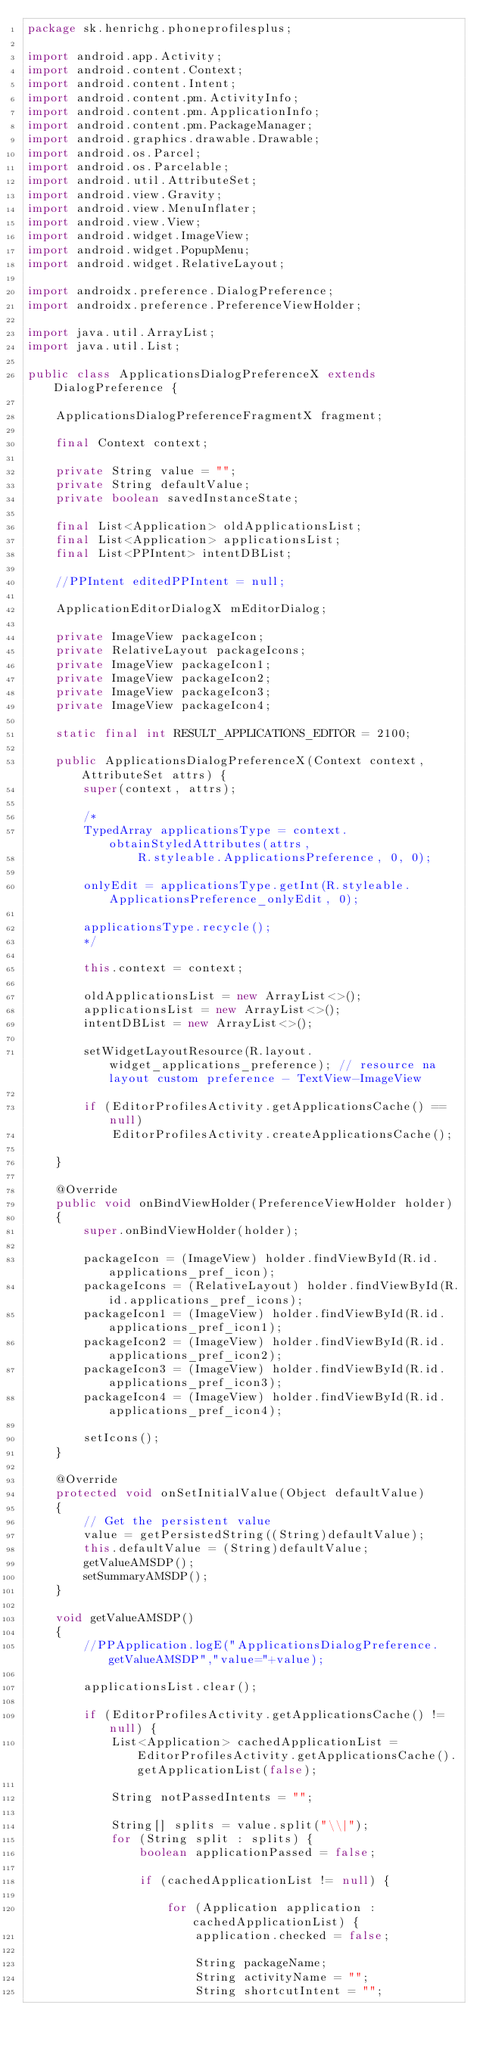Convert code to text. <code><loc_0><loc_0><loc_500><loc_500><_Java_>package sk.henrichg.phoneprofilesplus;

import android.app.Activity;
import android.content.Context;
import android.content.Intent;
import android.content.pm.ActivityInfo;
import android.content.pm.ApplicationInfo;
import android.content.pm.PackageManager;
import android.graphics.drawable.Drawable;
import android.os.Parcel;
import android.os.Parcelable;
import android.util.AttributeSet;
import android.view.Gravity;
import android.view.MenuInflater;
import android.view.View;
import android.widget.ImageView;
import android.widget.PopupMenu;
import android.widget.RelativeLayout;

import androidx.preference.DialogPreference;
import androidx.preference.PreferenceViewHolder;

import java.util.ArrayList;
import java.util.List;

public class ApplicationsDialogPreferenceX extends DialogPreference {

    ApplicationsDialogPreferenceFragmentX fragment;

    final Context context;

    private String value = "";
    private String defaultValue;
    private boolean savedInstanceState;

    final List<Application> oldApplicationsList;
    final List<Application> applicationsList;
    final List<PPIntent> intentDBList;

    //PPIntent editedPPIntent = null;

    ApplicationEditorDialogX mEditorDialog;

    private ImageView packageIcon;
    private RelativeLayout packageIcons;
    private ImageView packageIcon1;
    private ImageView packageIcon2;
    private ImageView packageIcon3;
    private ImageView packageIcon4;

    static final int RESULT_APPLICATIONS_EDITOR = 2100;

    public ApplicationsDialogPreferenceX(Context context, AttributeSet attrs) {
        super(context, attrs);

        /*
        TypedArray applicationsType = context.obtainStyledAttributes(attrs,
                R.styleable.ApplicationsPreference, 0, 0);

        onlyEdit = applicationsType.getInt(R.styleable.ApplicationsPreference_onlyEdit, 0);

        applicationsType.recycle();
        */

        this.context = context;

        oldApplicationsList = new ArrayList<>();
        applicationsList = new ArrayList<>();
        intentDBList = new ArrayList<>();

        setWidgetLayoutResource(R.layout.widget_applications_preference); // resource na layout custom preference - TextView-ImageView

        if (EditorProfilesActivity.getApplicationsCache() == null)
            EditorProfilesActivity.createApplicationsCache();

    }

    @Override
    public void onBindViewHolder(PreferenceViewHolder holder)
    {
        super.onBindViewHolder(holder);

        packageIcon = (ImageView) holder.findViewById(R.id.applications_pref_icon);
        packageIcons = (RelativeLayout) holder.findViewById(R.id.applications_pref_icons);
        packageIcon1 = (ImageView) holder.findViewById(R.id.applications_pref_icon1);
        packageIcon2 = (ImageView) holder.findViewById(R.id.applications_pref_icon2);
        packageIcon3 = (ImageView) holder.findViewById(R.id.applications_pref_icon3);
        packageIcon4 = (ImageView) holder.findViewById(R.id.applications_pref_icon4);

        setIcons();
    }

    @Override
    protected void onSetInitialValue(Object defaultValue)
    {
        // Get the persistent value
        value = getPersistedString((String)defaultValue);
        this.defaultValue = (String)defaultValue;
        getValueAMSDP();
        setSummaryAMSDP();
    }

    void getValueAMSDP()
    {
        //PPApplication.logE("ApplicationsDialogPreference.getValueAMSDP","value="+value);

        applicationsList.clear();

        if (EditorProfilesActivity.getApplicationsCache() != null) {
            List<Application> cachedApplicationList = EditorProfilesActivity.getApplicationsCache().getApplicationList(false);

            String notPassedIntents = "";

            String[] splits = value.split("\\|");
            for (String split : splits) {
                boolean applicationPassed = false;

                if (cachedApplicationList != null) {

                    for (Application application : cachedApplicationList) {
                        application.checked = false;

                        String packageName;
                        String activityName = "";
                        String shortcutIntent = "";</code> 